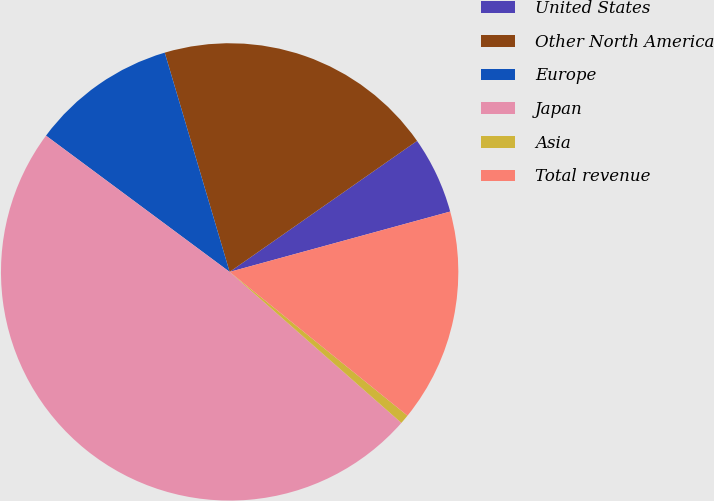Convert chart to OTSL. <chart><loc_0><loc_0><loc_500><loc_500><pie_chart><fcel>United States<fcel>Other North America<fcel>Europe<fcel>Japan<fcel>Asia<fcel>Total revenue<nl><fcel>5.46%<fcel>19.87%<fcel>10.26%<fcel>48.68%<fcel>0.66%<fcel>15.07%<nl></chart> 